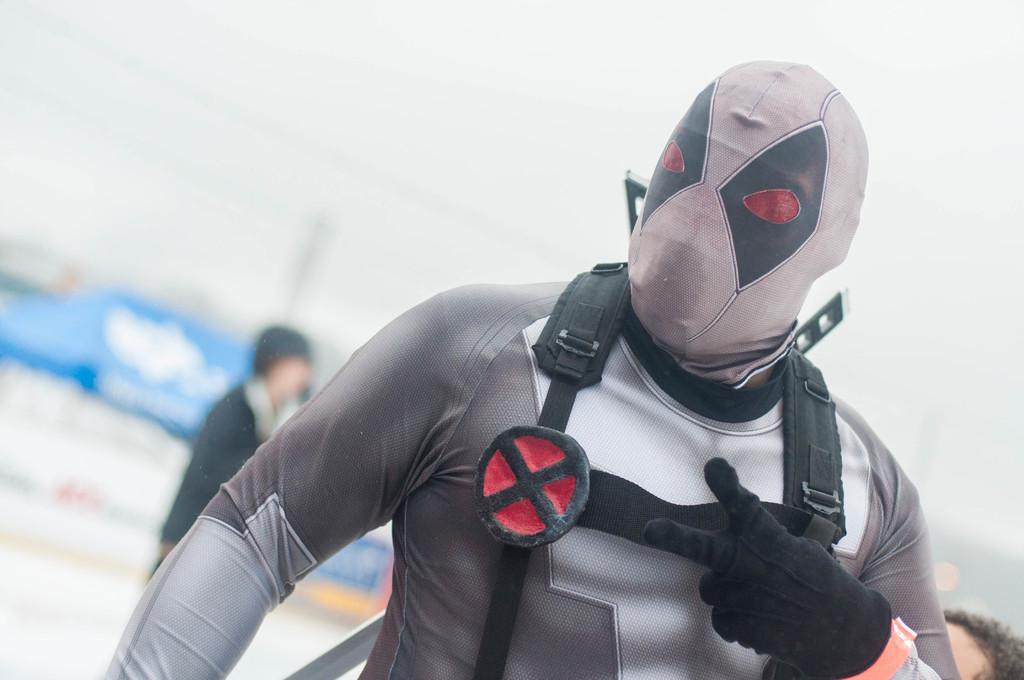Can you describe this image briefly? In front of the image there is a person wearing a mask. Behind him there are a few other people. In the background of the image there is a building. At the top of the image there is sky. 